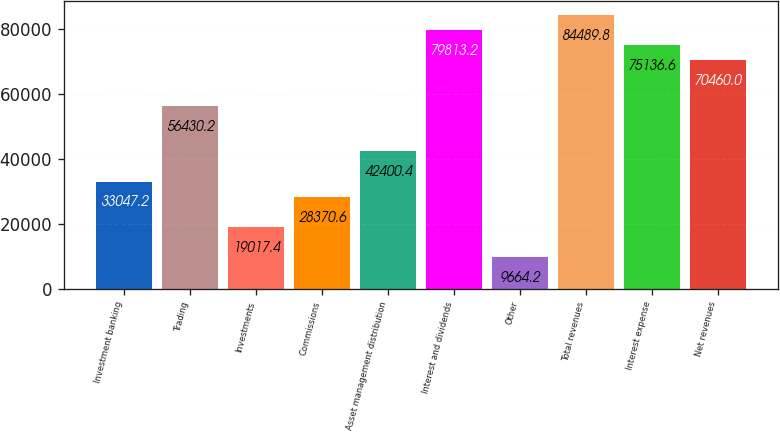<chart> <loc_0><loc_0><loc_500><loc_500><bar_chart><fcel>Investment banking<fcel>Trading<fcel>Investments<fcel>Commissions<fcel>Asset management distribution<fcel>Interest and dividends<fcel>Other<fcel>Total revenues<fcel>Interest expense<fcel>Net revenues<nl><fcel>33047.2<fcel>56430.2<fcel>19017.4<fcel>28370.6<fcel>42400.4<fcel>79813.2<fcel>9664.2<fcel>84489.8<fcel>75136.6<fcel>70460<nl></chart> 